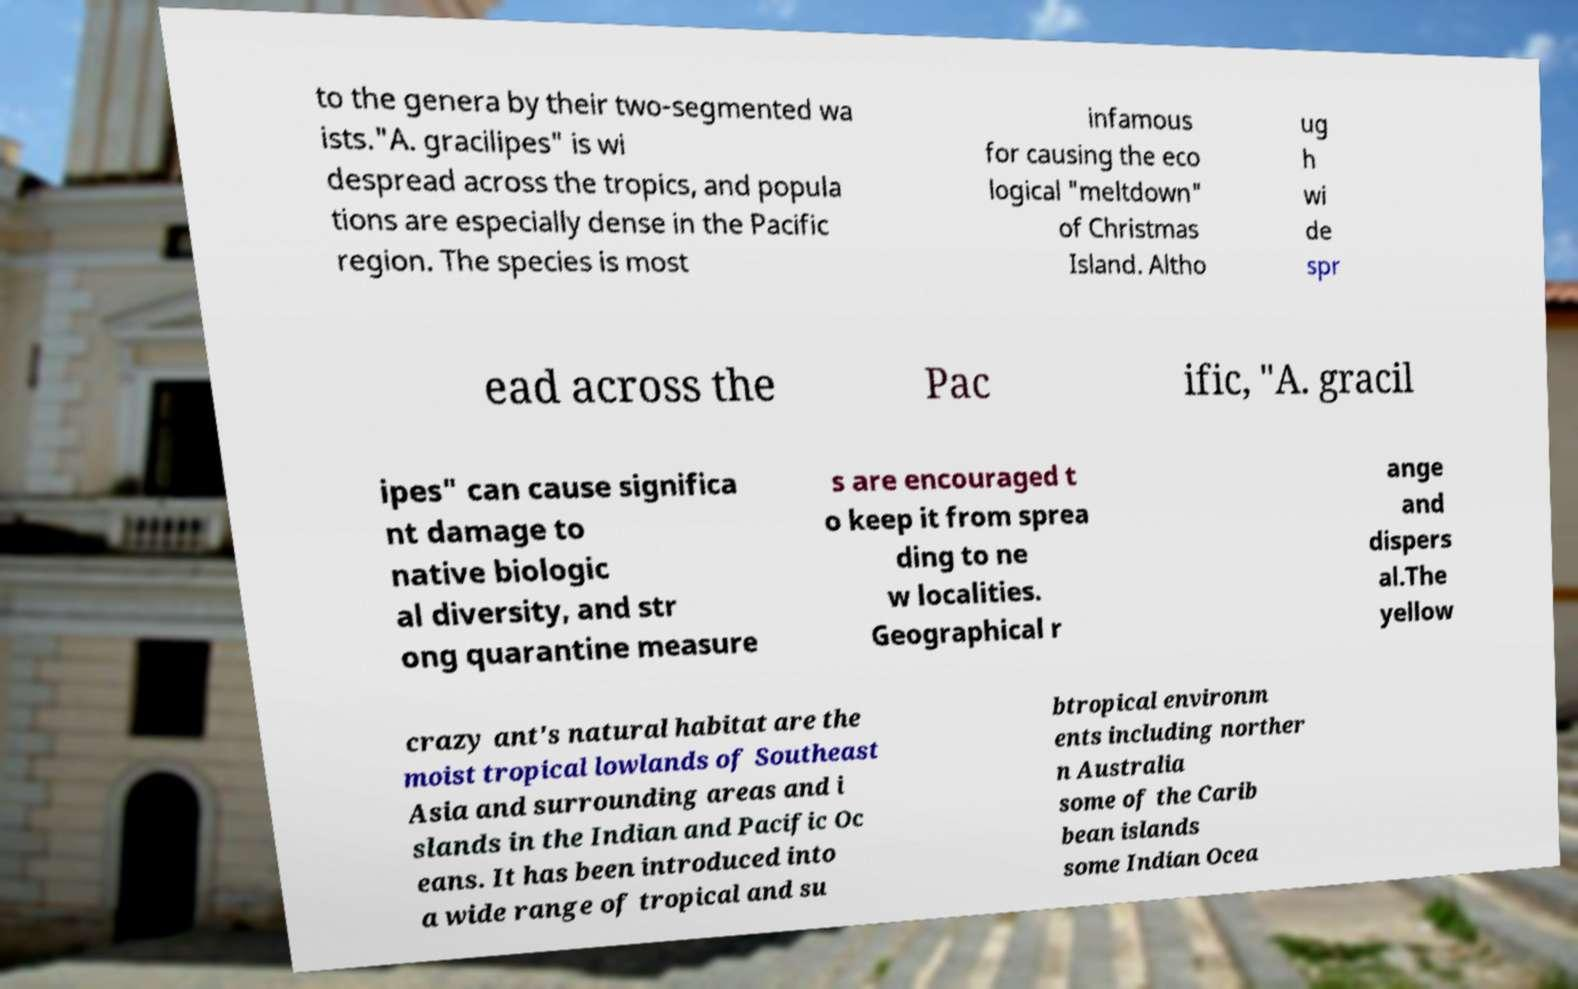Please read and relay the text visible in this image. What does it say? to the genera by their two-segmented wa ists."A. gracilipes" is wi despread across the tropics, and popula tions are especially dense in the Pacific region. The species is most infamous for causing the eco logical "meltdown" of Christmas Island. Altho ug h wi de spr ead across the Pac ific, "A. gracil ipes" can cause significa nt damage to native biologic al diversity, and str ong quarantine measure s are encouraged t o keep it from sprea ding to ne w localities. Geographical r ange and dispers al.The yellow crazy ant's natural habitat are the moist tropical lowlands of Southeast Asia and surrounding areas and i slands in the Indian and Pacific Oc eans. It has been introduced into a wide range of tropical and su btropical environm ents including norther n Australia some of the Carib bean islands some Indian Ocea 